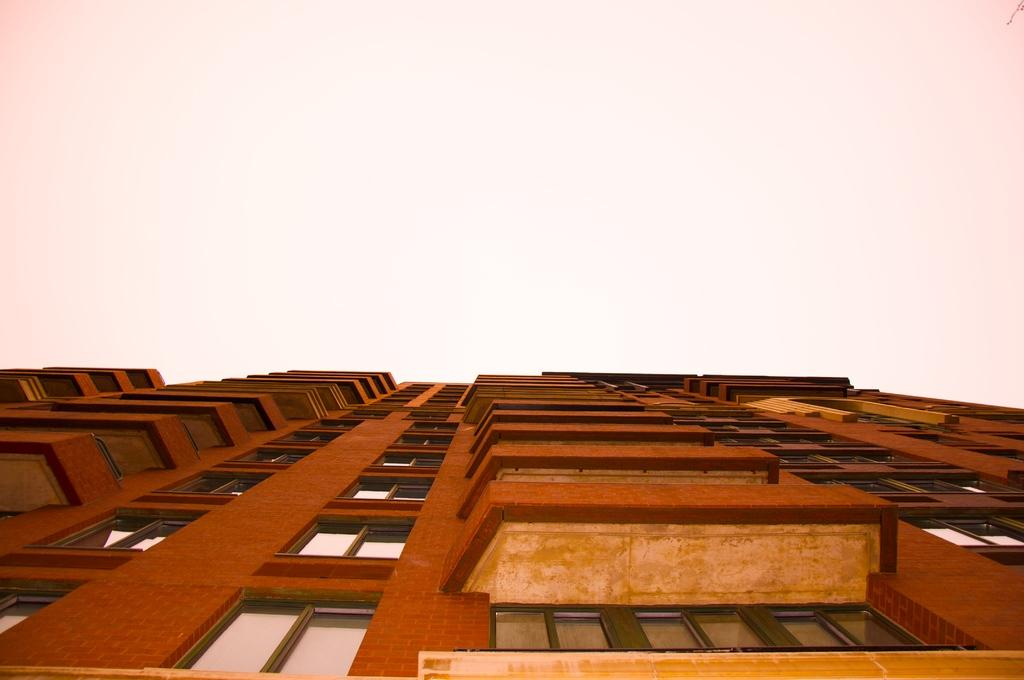What is the main structure in the image? There is a building in the image. What feature can be seen on the building? The building has windows. What else is visible in the image besides the building? The sky is visible in the image. What book is the building reading in the image? There is no book present in the image, and buildings do not read books. 